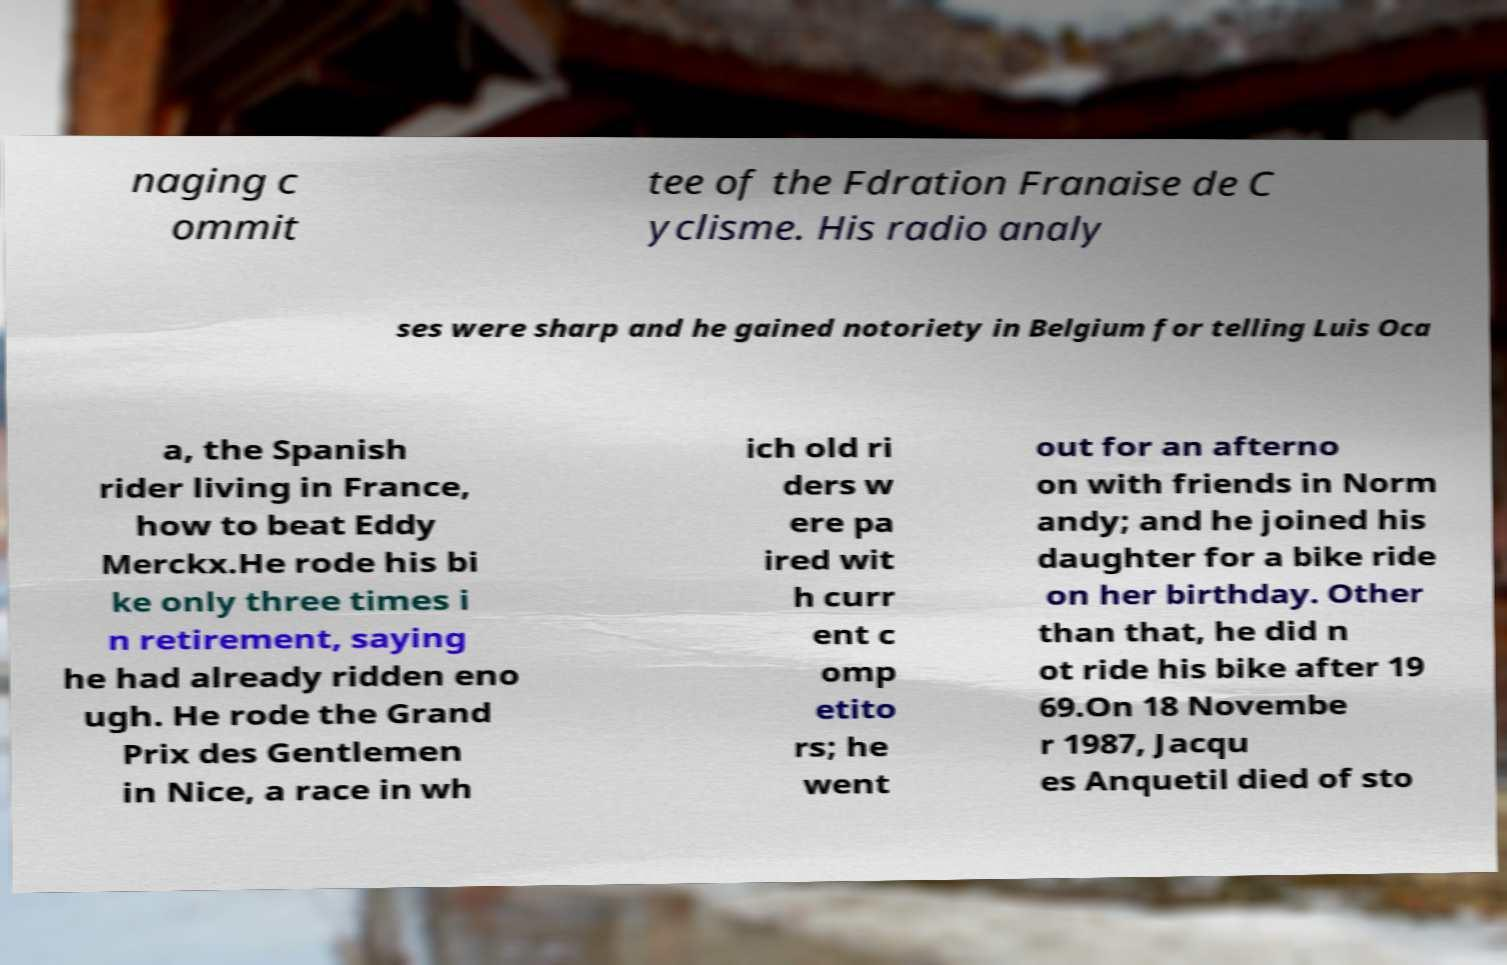I need the written content from this picture converted into text. Can you do that? naging c ommit tee of the Fdration Franaise de C yclisme. His radio analy ses were sharp and he gained notoriety in Belgium for telling Luis Oca a, the Spanish rider living in France, how to beat Eddy Merckx.He rode his bi ke only three times i n retirement, saying he had already ridden eno ugh. He rode the Grand Prix des Gentlemen in Nice, a race in wh ich old ri ders w ere pa ired wit h curr ent c omp etito rs; he went out for an afterno on with friends in Norm andy; and he joined his daughter for a bike ride on her birthday. Other than that, he did n ot ride his bike after 19 69.On 18 Novembe r 1987, Jacqu es Anquetil died of sto 